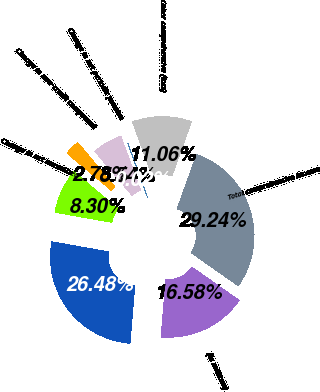Convert chart to OTSL. <chart><loc_0><loc_0><loc_500><loc_500><pie_chart><fcel>(in millions)<fcel>Net income<fcel>Change in net unrealized<fcel>Change in non-credit component<fcel>Change in net periodic pension<fcel>Foreign currency translation<fcel>Other comprehensive (loss)<fcel>Total comprehensive income<nl><fcel>16.58%<fcel>26.48%<fcel>8.3%<fcel>2.78%<fcel>5.54%<fcel>0.02%<fcel>11.06%<fcel>29.24%<nl></chart> 